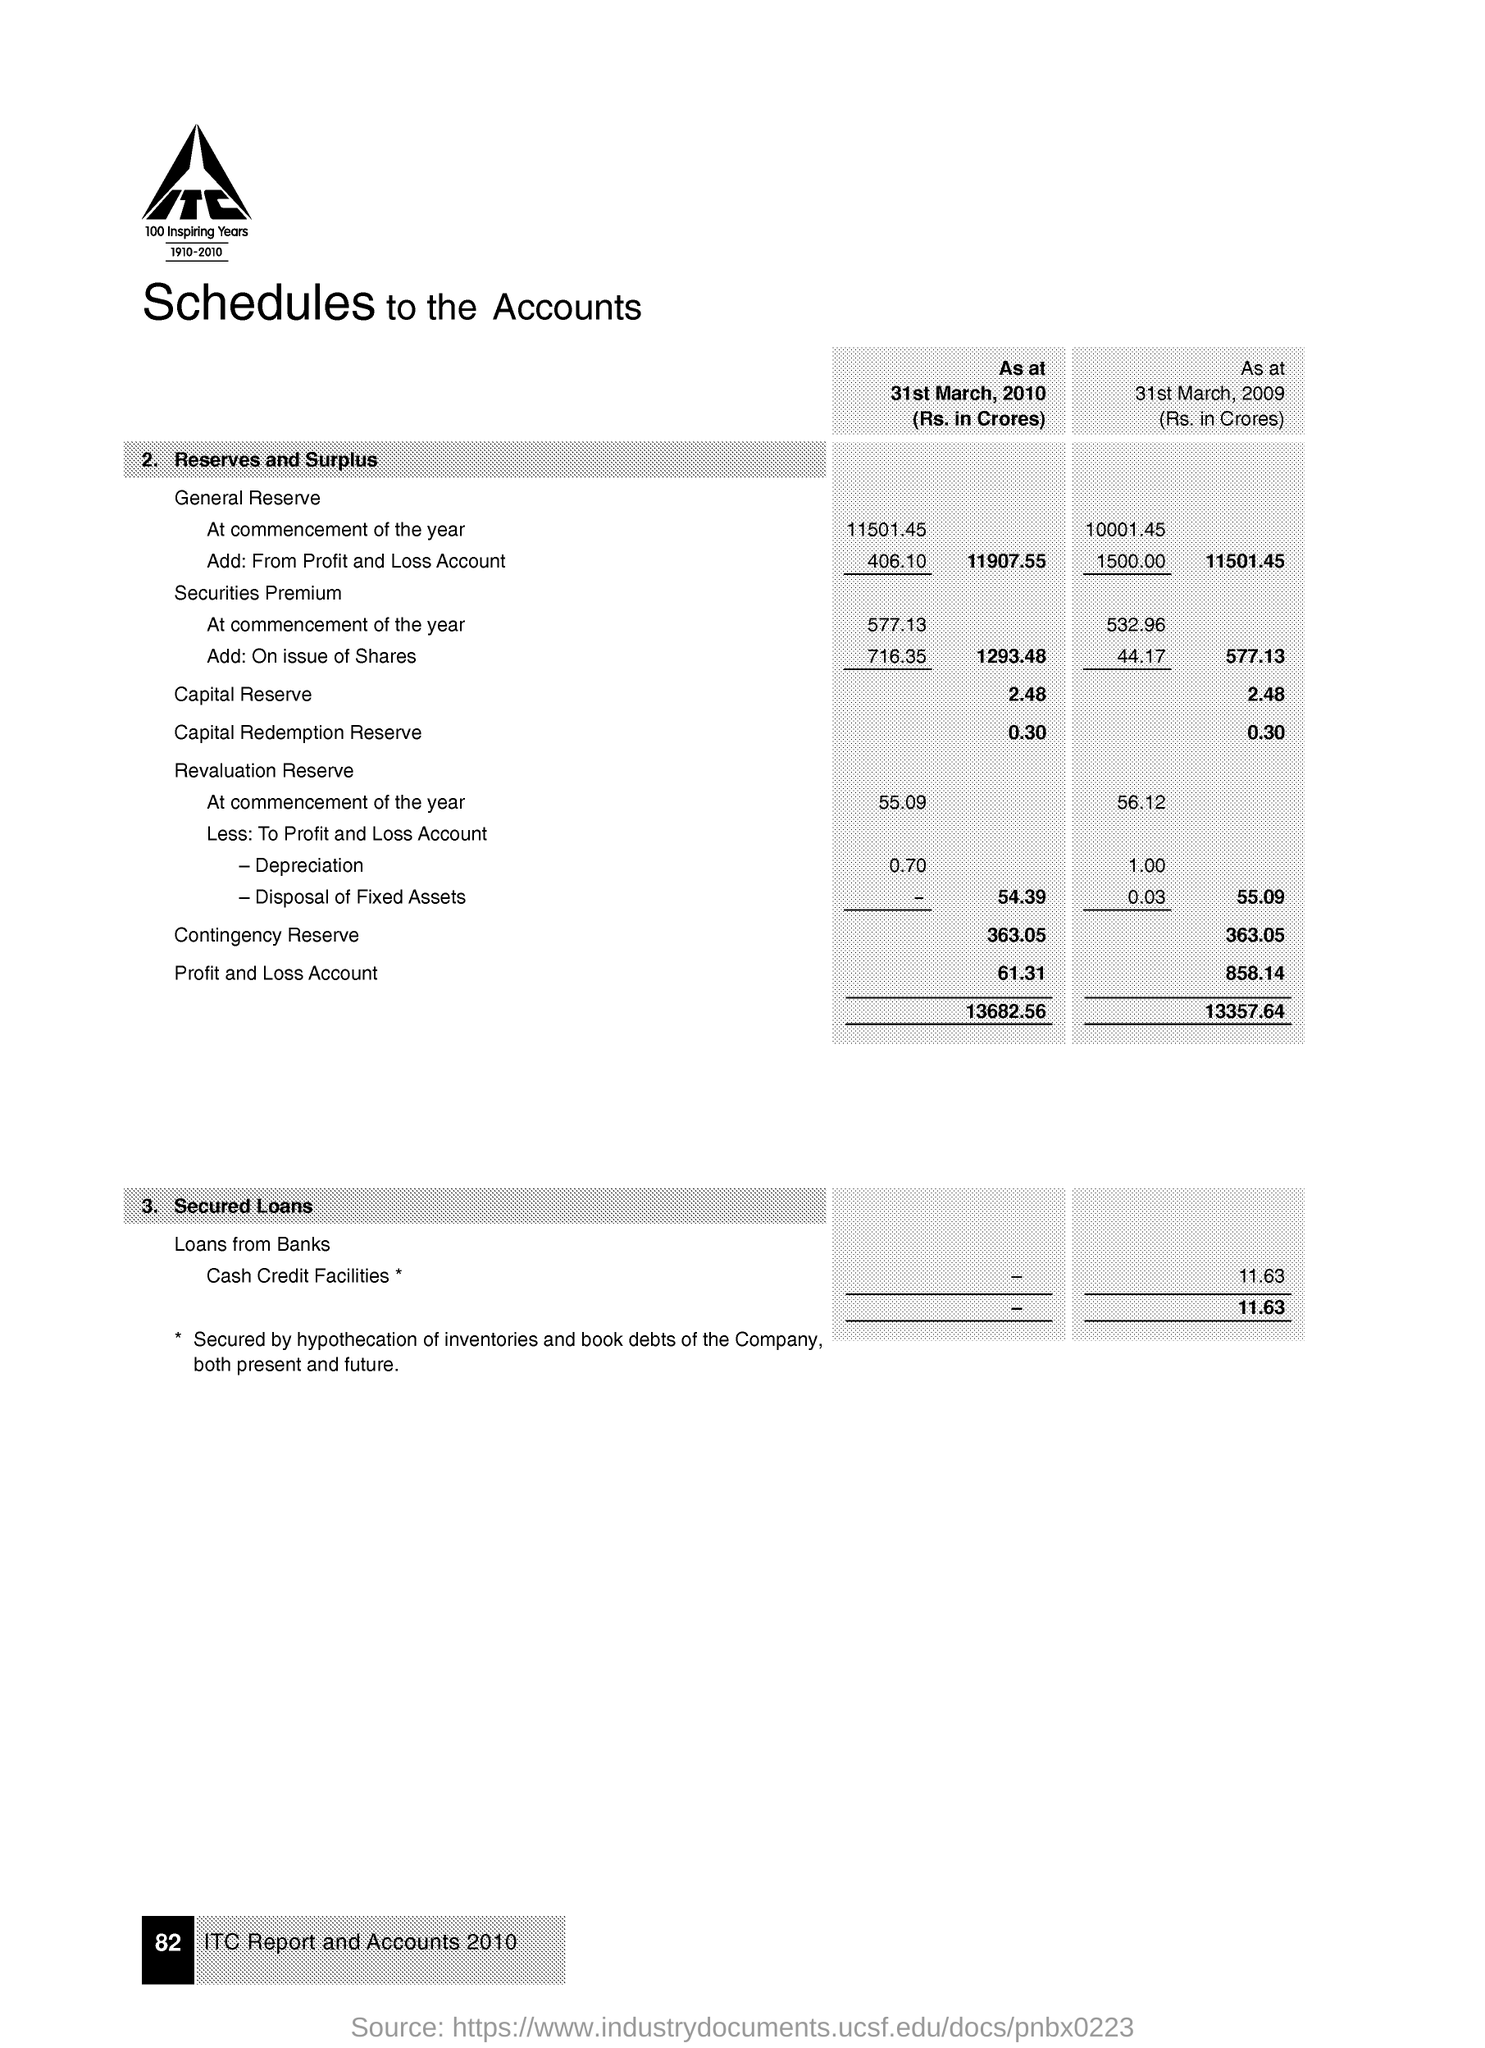What is the Capital Reserve as at 31st March, 2010 (Rs. in Crores)?
Ensure brevity in your answer.  2.48. What is the Contingency Reserve as at 31st March, 2009 (Rs. in Crores)?
Your answer should be very brief. 363.05. 